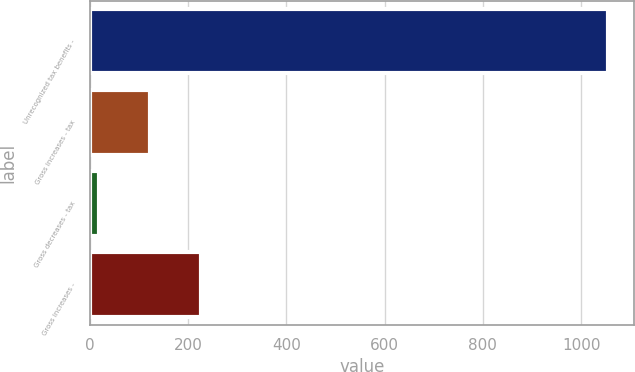<chart> <loc_0><loc_0><loc_500><loc_500><bar_chart><fcel>Unrecognized tax benefits -<fcel>Gross increases - tax<fcel>Gross decreases - tax<fcel>Gross increases -<nl><fcel>1055<fcel>123.5<fcel>20<fcel>227<nl></chart> 